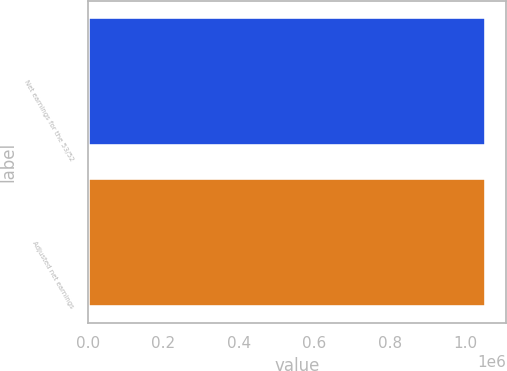Convert chart. <chart><loc_0><loc_0><loc_500><loc_500><bar_chart><fcel>Net earnings for the 53/52<fcel>Adjusted net earnings<nl><fcel>1.05595e+06<fcel>1.05595e+06<nl></chart> 